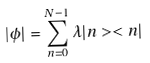<formula> <loc_0><loc_0><loc_500><loc_500>| \phi | = \sum _ { n = 0 } ^ { N - 1 } \lambda | n > < n |</formula> 